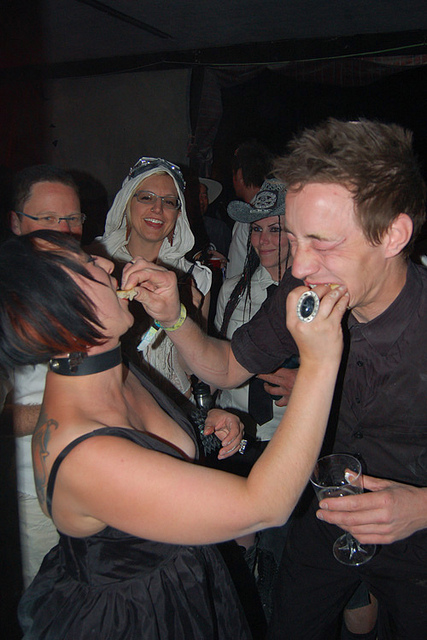<image>What are the children playing? There are no children in the image. What are the children playing? I don't know what the children are playing. There may be no children in the image or they are not playing anything. 